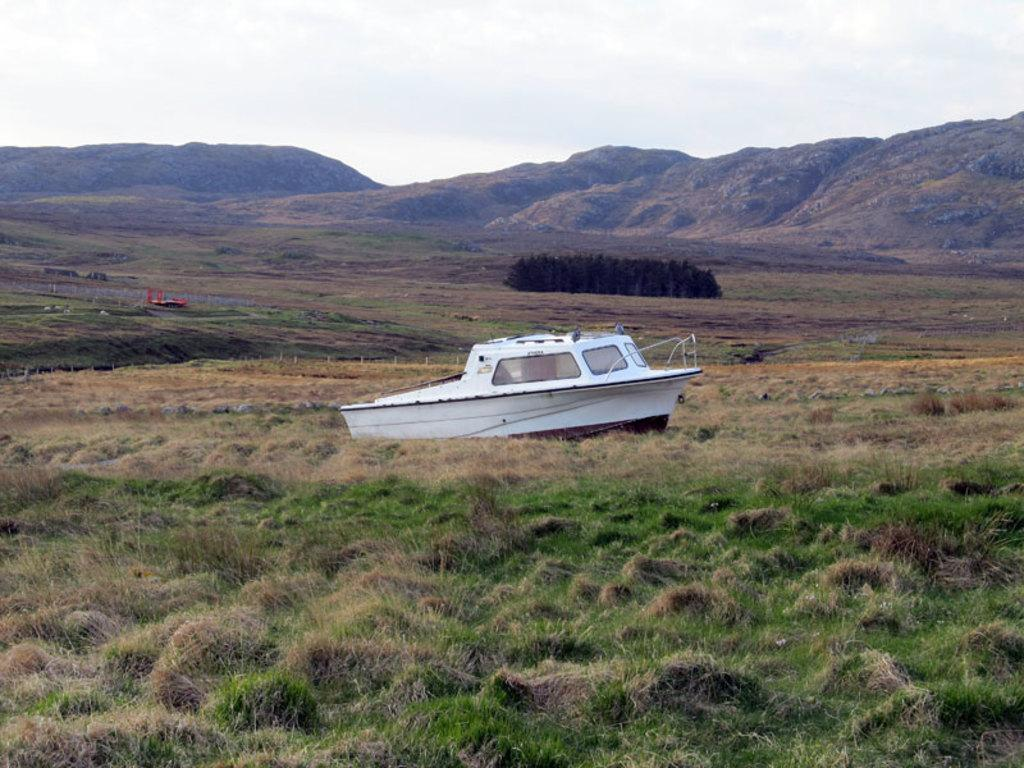What is the main subject of the picture? The main subject of the picture is a boat. What type of terrain is visible in the picture? There is grass on the ground in the picture. What other natural elements can be seen in the picture? There are plants and mountains in the picture. What is the condition of the sky in the picture? The sky is clear in the picture. What type of juice is being served in the carriage in the image? There is no carriage or juice present in the image; it features a boat and a clear sky. What question is being asked by the plant in the picture? There is no plant asking a question in the image; plants do not have the ability to ask questions. 